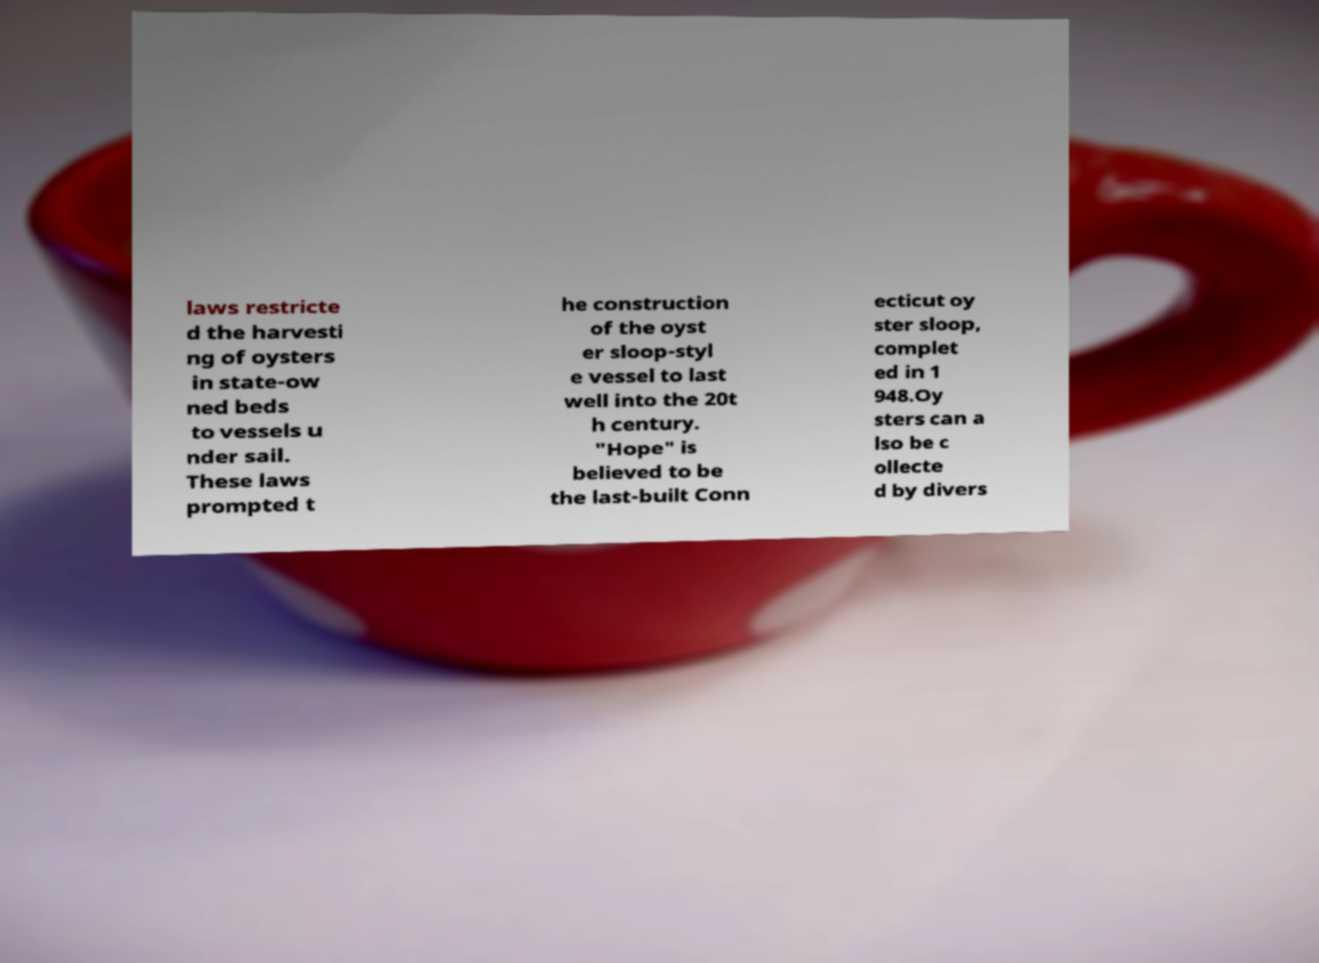Could you assist in decoding the text presented in this image and type it out clearly? laws restricte d the harvesti ng of oysters in state-ow ned beds to vessels u nder sail. These laws prompted t he construction of the oyst er sloop-styl e vessel to last well into the 20t h century. "Hope" is believed to be the last-built Conn ecticut oy ster sloop, complet ed in 1 948.Oy sters can a lso be c ollecte d by divers 